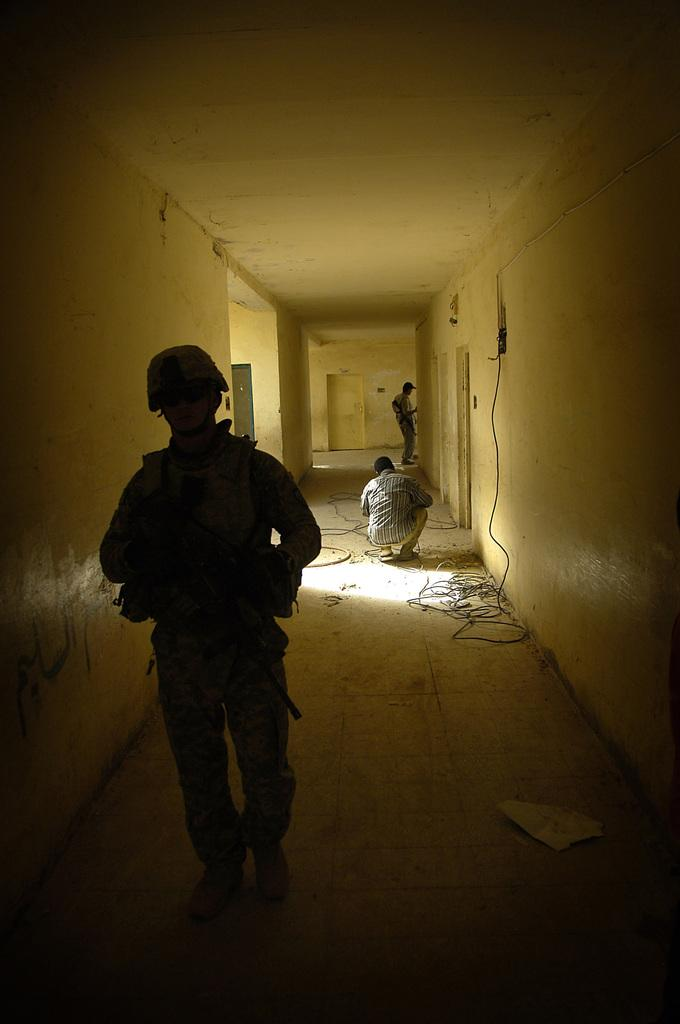How many people are in the image? There are people in the image, but the exact number is not specified. What is one person doing in the image? One person is in a squat position. What are the other people doing in the image? The other people are standing. What can be seen in the background of the image? There are wires, walls, and a ceiling visible in the image. What else is on the floor in the image? There are other objects on the floor. What type of marble is visible on the person's elbow in the image? There is no marble or elbow visible in the image. 